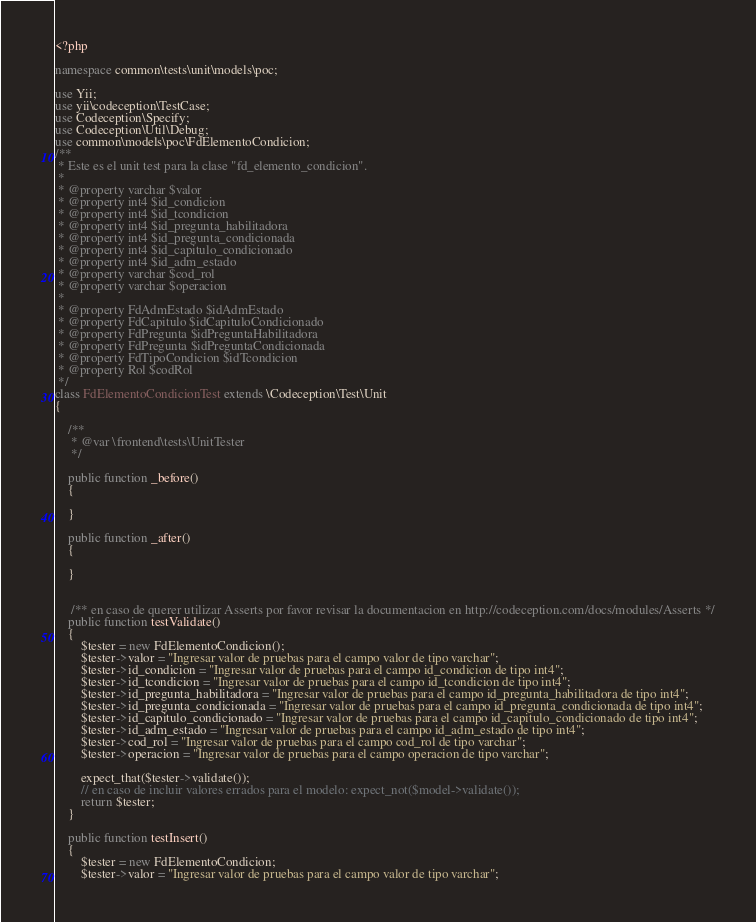<code> <loc_0><loc_0><loc_500><loc_500><_PHP_><?php

namespace common\tests\unit\models\poc;

use Yii;
use yii\codeception\TestCase;
use Codeception\Specify;
use Codeception\Util\Debug;
use common\models\poc\FdElementoCondicion;
/**
 * Este es el unit test para la clase "fd_elemento_condicion".
 *
 * @property varchar $valor
 * @property int4 $id_condicion
 * @property int4 $id_tcondicion
 * @property int4 $id_pregunta_habilitadora
 * @property int4 $id_pregunta_condicionada
 * @property int4 $id_capitulo_condicionado
 * @property int4 $id_adm_estado
 * @property varchar $cod_rol
 * @property varchar $operacion
 *
 * @property FdAdmEstado $idAdmEstado
 * @property FdCapitulo $idCapituloCondicionado
 * @property FdPregunta $idPreguntaHabilitadora
 * @property FdPregunta $idPreguntaCondicionada
 * @property FdTipoCondicion $idTcondicion
 * @property Rol $codRol
 */
class FdElementoCondicionTest extends \Codeception\Test\Unit
{

    /**
     * @var \frontend\tests\UnitTester
     */

    public function _before()
    {
        
    }
                                                                                        
    public function _after()                                                              
    {             
                                                             
    }                
    
    
     /** en caso de querer utilizar Asserts por favor revisar la documentacion en http://codeception.com/docs/modules/Asserts */
    public function testValidate()                                                             
    {                                                                                        
        $tester = new FdElementoCondicion();
        $tester->valor = "Ingresar valor de pruebas para el campo valor de tipo varchar";
        $tester->id_condicion = "Ingresar valor de pruebas para el campo id_condicion de tipo int4";
        $tester->id_tcondicion = "Ingresar valor de pruebas para el campo id_tcondicion de tipo int4";
        $tester->id_pregunta_habilitadora = "Ingresar valor de pruebas para el campo id_pregunta_habilitadora de tipo int4";
        $tester->id_pregunta_condicionada = "Ingresar valor de pruebas para el campo id_pregunta_condicionada de tipo int4";
        $tester->id_capitulo_condicionado = "Ingresar valor de pruebas para el campo id_capitulo_condicionado de tipo int4";
        $tester->id_adm_estado = "Ingresar valor de pruebas para el campo id_adm_estado de tipo int4";
        $tester->cod_rol = "Ingresar valor de pruebas para el campo cod_rol de tipo varchar";
        $tester->operacion = "Ingresar valor de pruebas para el campo operacion de tipo varchar";
            
        expect_that($tester->validate());
        // en caso de incluir valores errados para el modelo: expect_not($model->validate());
        return $tester;
    }
    
    public function testInsert()                                                             
    {                                                                                        
        $tester = new FdElementoCondicion;
        $tester->valor = "Ingresar valor de pruebas para el campo valor de tipo varchar";</code> 